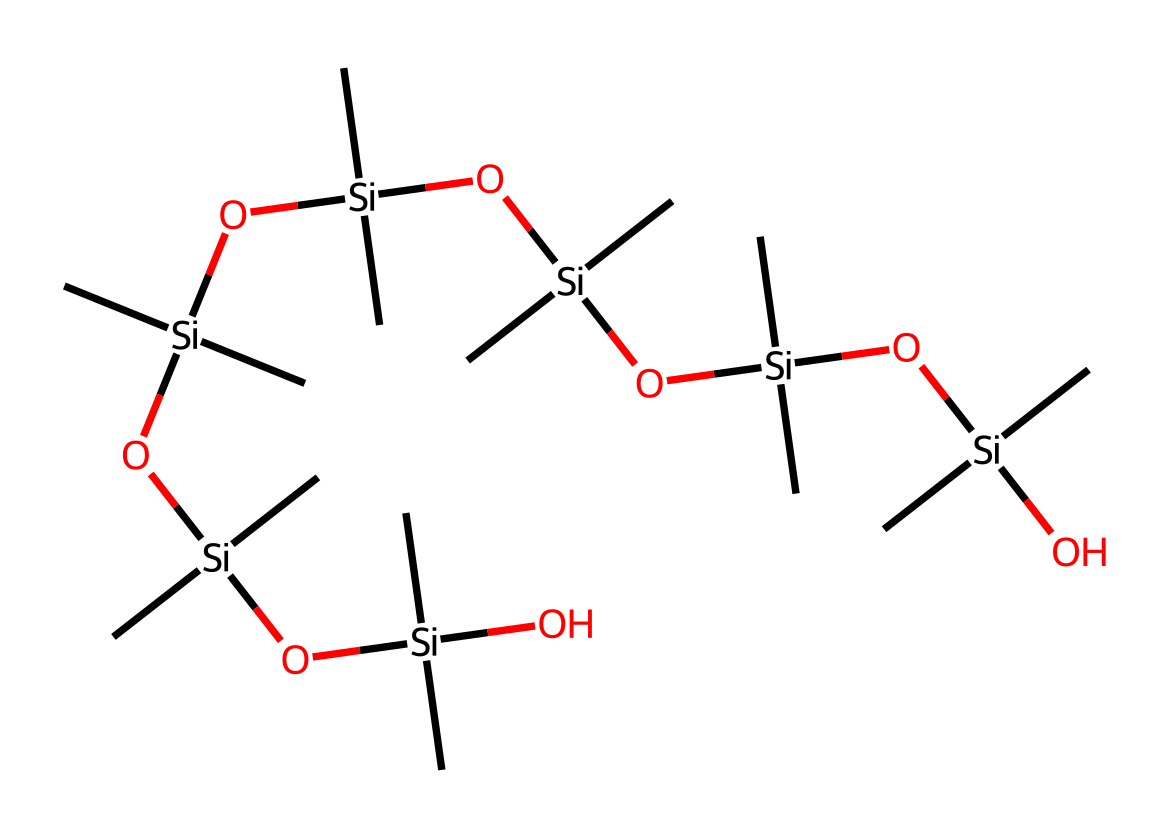What is the main element in this chemical structure? Upon analyzing the provided SMILES, the central element that appears is silicon, which is represented by 'Si' in the structure. Since the compound is primarily comprised of silicon and carbon, with multiple silicon atoms, we can conclude that silicon is the main element.
Answer: silicon How many silicon atoms are present in this compound? By breaking down the SMILES representation, we can identify the silicon atoms represented by the 'Si' notation. Counting the occurrences of 'Si' gives us a total of eight silicon atoms present in the structure.
Answer: eight What functional groups are present in this structure? The given SMILES displays the silanol functional group (–Si–OH) due to the presence of the oxygen atom connected to silicon. This indicates that the structure has silanol functional groups throughout, allowing for properties associated with organosilicon compounds.
Answer: silanol What is a likely physical property of this compound based on its structure? The structure includes numerous silicon and carbon atoms, indicating it has a high molecular weight and is likely to be hydrophobic (water-repelling), which is a common characteristic of silicone-based compounds, especially in applications like car wax.
Answer: hydrophobic How many carbon atoms are attached to each silicon atom in the backbone? Examining the structure, each 'Si' is connected to three methyl groups (–C) represented in the SMILES by '(C)(C)(C)', indicating that there are three carbon atoms attached to each silicon atom in the backbone of the structure.
Answer: three What characteristic does this structure contribute to its use in car wax? The branching and repeating siloxane links (–Si–O–Si–) in the SMILES representation imply a polymeric nature, which enhances the gloss and protective qualities of the wax film on car surfaces. This polymeric structure is key to its effectiveness.
Answer: polymeric nature What type of bonding primarily holds this compound together? The structure shows siloxane bonds (Si–O), which are the result of covalent bonding between silicon and oxygen atoms. This strong bonding type provides stability and durability to the wax compound.
Answer: covalent bonding 